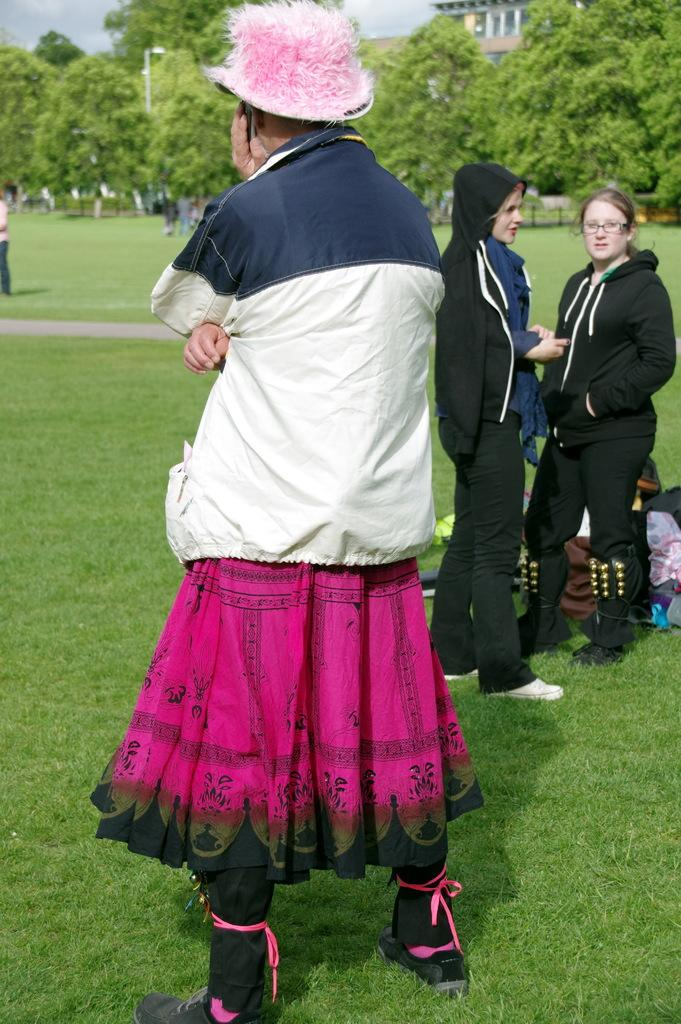What are the people in the image doing? The people in the image are standing in the center. What can be seen at the bottom of the image? There are clothes and grass at the bottom of the image. What is visible in the background of the image? There are trees, a building, and the sky visible in the background of the image. What type of box can be seen in the image? There is no box present in the image. 